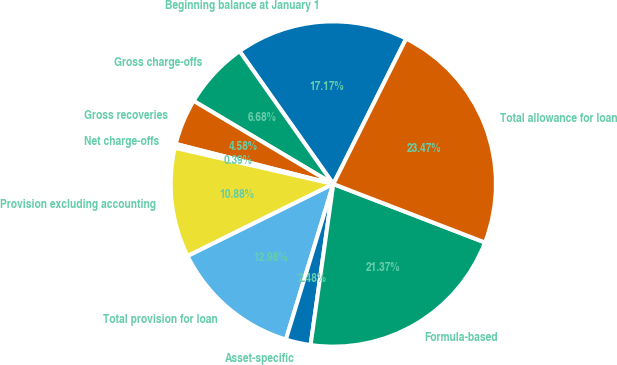Convert chart to OTSL. <chart><loc_0><loc_0><loc_500><loc_500><pie_chart><fcel>Beginning balance at January 1<fcel>Gross charge-offs<fcel>Gross recoveries<fcel>Net charge-offs<fcel>Provision excluding accounting<fcel>Total provision for loan<fcel>Asset-specific<fcel>Formula-based<fcel>Total allowance for loan<nl><fcel>17.17%<fcel>6.68%<fcel>4.58%<fcel>0.39%<fcel>10.88%<fcel>12.98%<fcel>2.48%<fcel>21.37%<fcel>23.47%<nl></chart> 